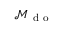Convert formula to latex. <formula><loc_0><loc_0><loc_500><loc_500>{ { \mathcal { M } } _ { d o } }</formula> 